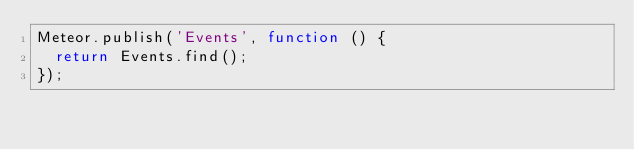<code> <loc_0><loc_0><loc_500><loc_500><_JavaScript_>Meteor.publish('Events', function () {
  return Events.find();
});</code> 